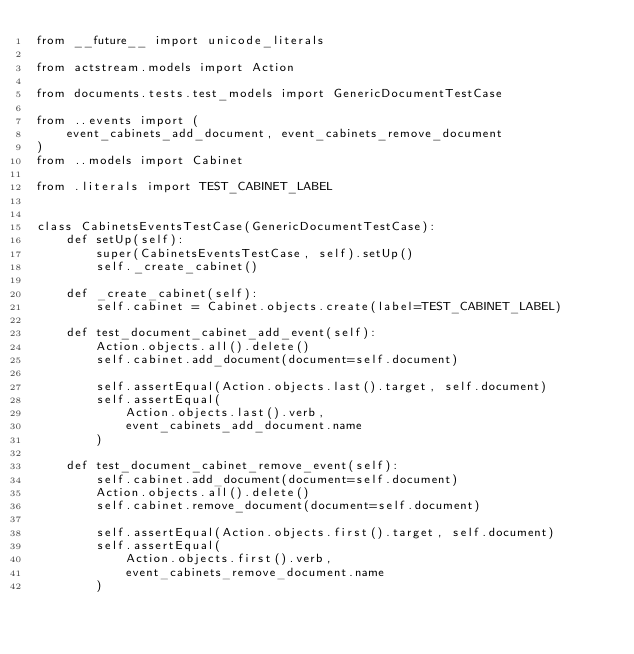<code> <loc_0><loc_0><loc_500><loc_500><_Python_>from __future__ import unicode_literals

from actstream.models import Action

from documents.tests.test_models import GenericDocumentTestCase

from ..events import (
    event_cabinets_add_document, event_cabinets_remove_document
)
from ..models import Cabinet

from .literals import TEST_CABINET_LABEL


class CabinetsEventsTestCase(GenericDocumentTestCase):
    def setUp(self):
        super(CabinetsEventsTestCase, self).setUp()
        self._create_cabinet()

    def _create_cabinet(self):
        self.cabinet = Cabinet.objects.create(label=TEST_CABINET_LABEL)

    def test_document_cabinet_add_event(self):
        Action.objects.all().delete()
        self.cabinet.add_document(document=self.document)

        self.assertEqual(Action.objects.last().target, self.document)
        self.assertEqual(
            Action.objects.last().verb,
            event_cabinets_add_document.name
        )

    def test_document_cabinet_remove_event(self):
        self.cabinet.add_document(document=self.document)
        Action.objects.all().delete()
        self.cabinet.remove_document(document=self.document)

        self.assertEqual(Action.objects.first().target, self.document)
        self.assertEqual(
            Action.objects.first().verb,
            event_cabinets_remove_document.name
        )
</code> 